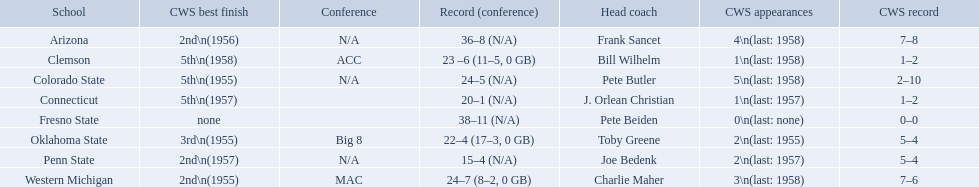What are the teams in the conference? Arizona, Clemson, Colorado State, Connecticut, Fresno State, Oklahoma State, Penn State, Western Michigan. Which have more than 16 wins? Arizona, Clemson, Colorado State, Connecticut, Fresno State, Oklahoma State, Western Michigan. Which had less than 16 wins? Penn State. What are the listed schools? Arizona, Clemson, Colorado State, Connecticut, Fresno State, Oklahoma State, Penn State, Western Michigan. Which are clemson and western michigan? Clemson, Western Michigan. What are their corresponding numbers of cws appearances? 1\n(last: 1958), 3\n(last: 1958). Which value is larger? 3\n(last: 1958). To which school does that value belong to? Western Michigan. 